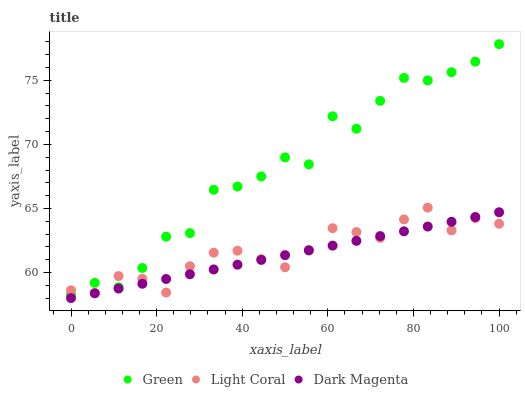Does Dark Magenta have the minimum area under the curve?
Answer yes or no. Yes. Does Green have the maximum area under the curve?
Answer yes or no. Yes. Does Green have the minimum area under the curve?
Answer yes or no. No. Does Dark Magenta have the maximum area under the curve?
Answer yes or no. No. Is Dark Magenta the smoothest?
Answer yes or no. Yes. Is Green the roughest?
Answer yes or no. Yes. Is Green the smoothest?
Answer yes or no. No. Is Dark Magenta the roughest?
Answer yes or no. No. Does Dark Magenta have the lowest value?
Answer yes or no. Yes. Does Green have the lowest value?
Answer yes or no. No. Does Green have the highest value?
Answer yes or no. Yes. Does Dark Magenta have the highest value?
Answer yes or no. No. Is Dark Magenta less than Green?
Answer yes or no. Yes. Is Green greater than Dark Magenta?
Answer yes or no. Yes. Does Light Coral intersect Green?
Answer yes or no. Yes. Is Light Coral less than Green?
Answer yes or no. No. Is Light Coral greater than Green?
Answer yes or no. No. Does Dark Magenta intersect Green?
Answer yes or no. No. 